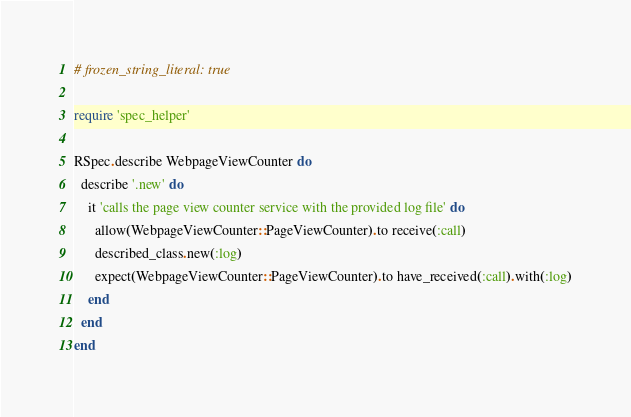Convert code to text. <code><loc_0><loc_0><loc_500><loc_500><_Ruby_># frozen_string_literal: true

require 'spec_helper'

RSpec.describe WebpageViewCounter do
  describe '.new' do
    it 'calls the page view counter service with the provided log file' do
      allow(WebpageViewCounter::PageViewCounter).to receive(:call)
      described_class.new(:log)
      expect(WebpageViewCounter::PageViewCounter).to have_received(:call).with(:log)
    end
  end
end
</code> 